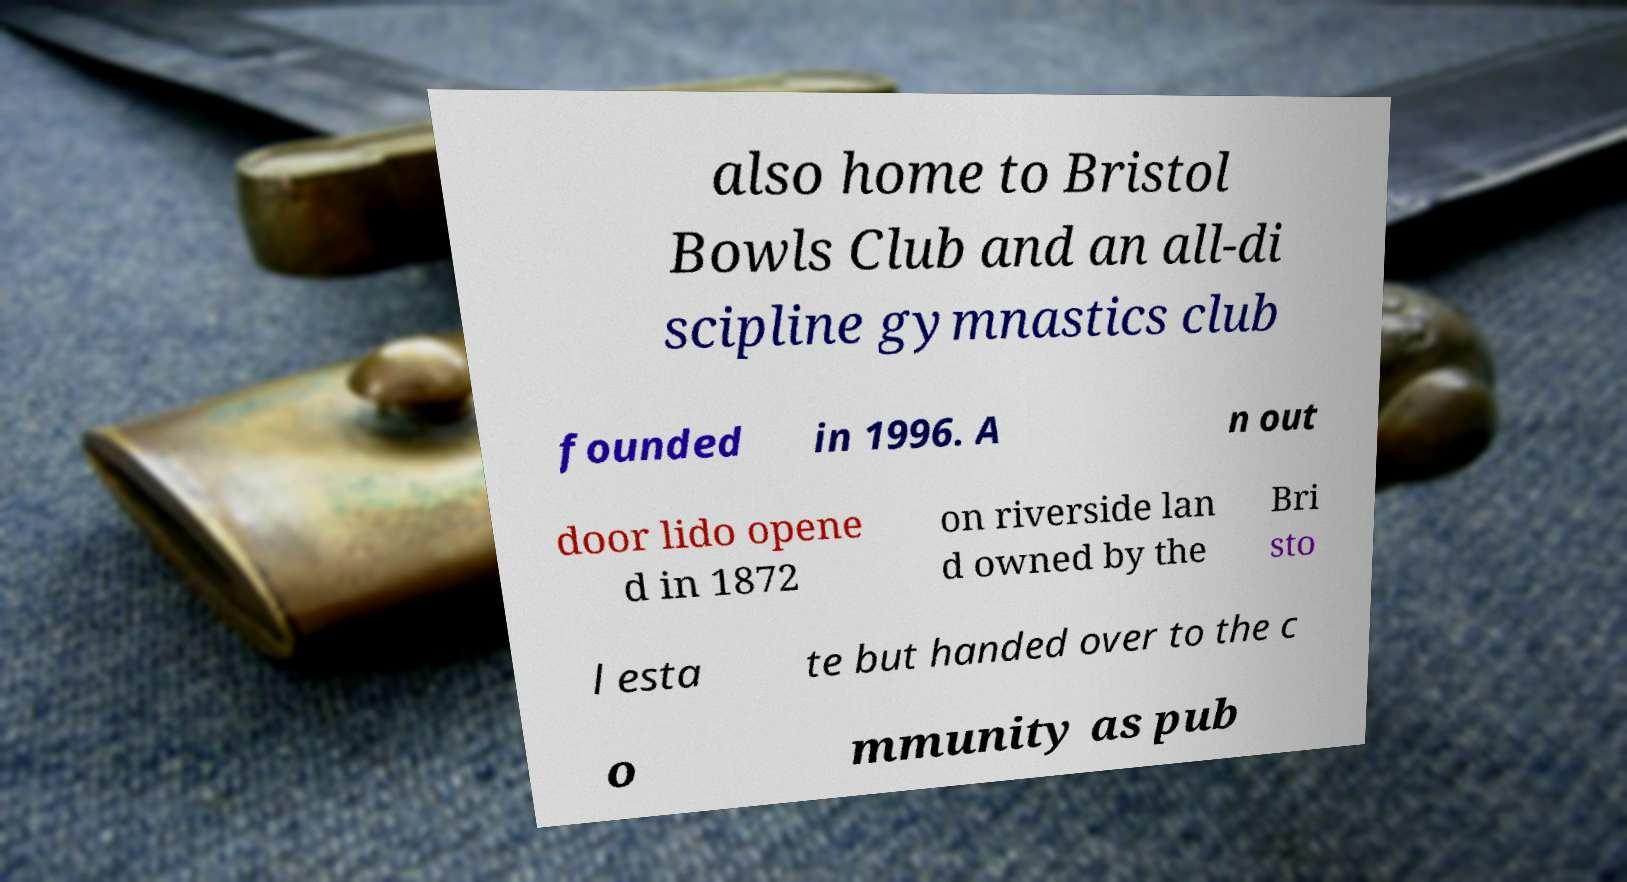Please identify and transcribe the text found in this image. also home to Bristol Bowls Club and an all-di scipline gymnastics club founded in 1996. A n out door lido opene d in 1872 on riverside lan d owned by the Bri sto l esta te but handed over to the c o mmunity as pub 